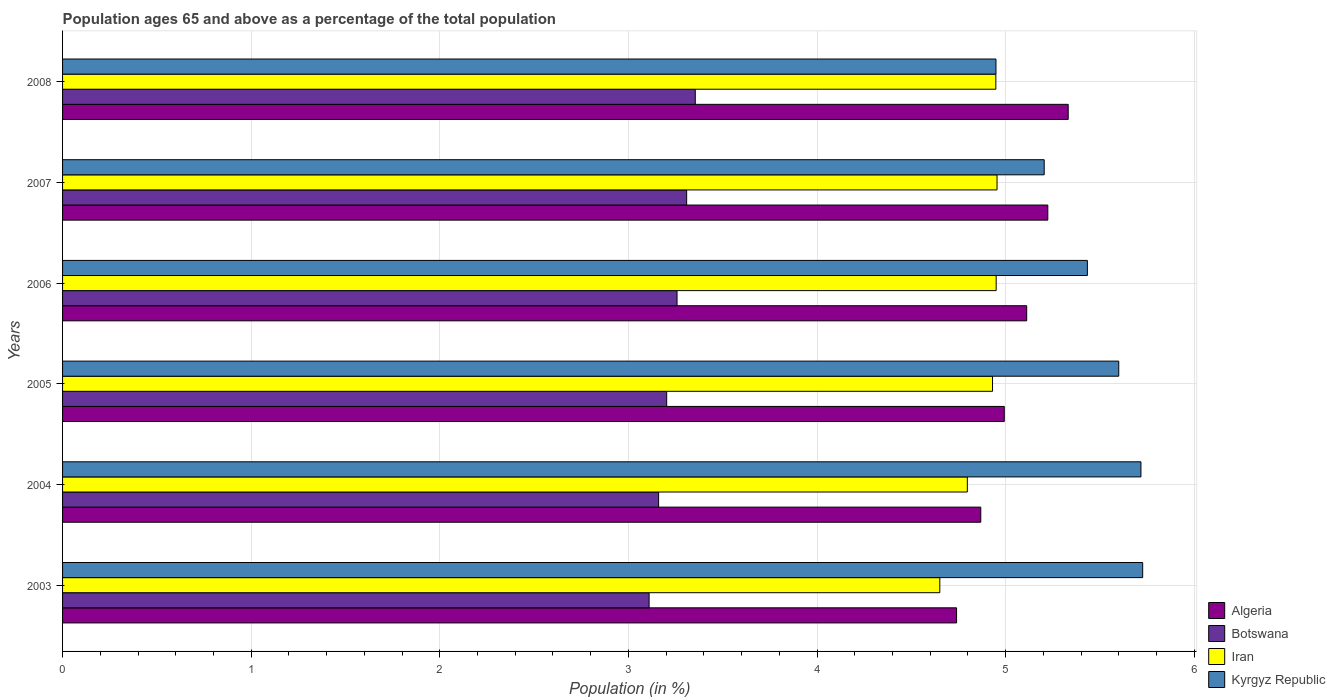Are the number of bars on each tick of the Y-axis equal?
Ensure brevity in your answer.  Yes. How many bars are there on the 2nd tick from the top?
Give a very brief answer. 4. What is the percentage of the population ages 65 and above in Botswana in 2008?
Make the answer very short. 3.35. Across all years, what is the maximum percentage of the population ages 65 and above in Iran?
Provide a succinct answer. 4.95. Across all years, what is the minimum percentage of the population ages 65 and above in Algeria?
Offer a terse response. 4.74. What is the total percentage of the population ages 65 and above in Algeria in the graph?
Offer a terse response. 30.27. What is the difference between the percentage of the population ages 65 and above in Algeria in 2006 and that in 2008?
Your answer should be very brief. -0.22. What is the difference between the percentage of the population ages 65 and above in Iran in 2005 and the percentage of the population ages 65 and above in Botswana in 2008?
Provide a short and direct response. 1.58. What is the average percentage of the population ages 65 and above in Botswana per year?
Offer a very short reply. 3.23. In the year 2008, what is the difference between the percentage of the population ages 65 and above in Botswana and percentage of the population ages 65 and above in Iran?
Provide a succinct answer. -1.59. In how many years, is the percentage of the population ages 65 and above in Iran greater than 4 ?
Your answer should be compact. 6. What is the ratio of the percentage of the population ages 65 and above in Algeria in 2004 to that in 2006?
Offer a very short reply. 0.95. Is the percentage of the population ages 65 and above in Kyrgyz Republic in 2004 less than that in 2007?
Keep it short and to the point. No. Is the difference between the percentage of the population ages 65 and above in Botswana in 2005 and 2008 greater than the difference between the percentage of the population ages 65 and above in Iran in 2005 and 2008?
Your answer should be compact. No. What is the difference between the highest and the second highest percentage of the population ages 65 and above in Kyrgyz Republic?
Keep it short and to the point. 0.01. What is the difference between the highest and the lowest percentage of the population ages 65 and above in Iran?
Your answer should be compact. 0.3. In how many years, is the percentage of the population ages 65 and above in Iran greater than the average percentage of the population ages 65 and above in Iran taken over all years?
Your answer should be very brief. 4. What does the 3rd bar from the top in 2008 represents?
Make the answer very short. Botswana. What does the 4th bar from the bottom in 2004 represents?
Your answer should be compact. Kyrgyz Republic. How many bars are there?
Provide a short and direct response. 24. Are all the bars in the graph horizontal?
Your answer should be compact. Yes. What is the difference between two consecutive major ticks on the X-axis?
Offer a very short reply. 1. Are the values on the major ticks of X-axis written in scientific E-notation?
Offer a terse response. No. Does the graph contain any zero values?
Offer a terse response. No. Does the graph contain grids?
Your answer should be compact. Yes. Where does the legend appear in the graph?
Ensure brevity in your answer.  Bottom right. What is the title of the graph?
Provide a short and direct response. Population ages 65 and above as a percentage of the total population. What is the Population (in %) in Algeria in 2003?
Ensure brevity in your answer.  4.74. What is the Population (in %) in Botswana in 2003?
Your response must be concise. 3.11. What is the Population (in %) in Iran in 2003?
Ensure brevity in your answer.  4.65. What is the Population (in %) in Kyrgyz Republic in 2003?
Your answer should be compact. 5.73. What is the Population (in %) in Algeria in 2004?
Ensure brevity in your answer.  4.87. What is the Population (in %) in Botswana in 2004?
Ensure brevity in your answer.  3.16. What is the Population (in %) in Iran in 2004?
Offer a very short reply. 4.8. What is the Population (in %) of Kyrgyz Republic in 2004?
Offer a terse response. 5.72. What is the Population (in %) of Algeria in 2005?
Your answer should be compact. 4.99. What is the Population (in %) in Botswana in 2005?
Provide a short and direct response. 3.2. What is the Population (in %) of Iran in 2005?
Provide a succinct answer. 4.93. What is the Population (in %) in Kyrgyz Republic in 2005?
Offer a terse response. 5.6. What is the Population (in %) in Algeria in 2006?
Your response must be concise. 5.11. What is the Population (in %) of Botswana in 2006?
Your answer should be compact. 3.26. What is the Population (in %) in Iran in 2006?
Offer a very short reply. 4.95. What is the Population (in %) of Kyrgyz Republic in 2006?
Keep it short and to the point. 5.43. What is the Population (in %) of Algeria in 2007?
Provide a succinct answer. 5.22. What is the Population (in %) of Botswana in 2007?
Provide a short and direct response. 3.31. What is the Population (in %) of Iran in 2007?
Ensure brevity in your answer.  4.95. What is the Population (in %) in Kyrgyz Republic in 2007?
Provide a short and direct response. 5.2. What is the Population (in %) in Algeria in 2008?
Make the answer very short. 5.33. What is the Population (in %) of Botswana in 2008?
Ensure brevity in your answer.  3.35. What is the Population (in %) in Iran in 2008?
Offer a terse response. 4.95. What is the Population (in %) of Kyrgyz Republic in 2008?
Provide a short and direct response. 4.95. Across all years, what is the maximum Population (in %) of Algeria?
Offer a terse response. 5.33. Across all years, what is the maximum Population (in %) of Botswana?
Offer a very short reply. 3.35. Across all years, what is the maximum Population (in %) of Iran?
Give a very brief answer. 4.95. Across all years, what is the maximum Population (in %) of Kyrgyz Republic?
Your response must be concise. 5.73. Across all years, what is the minimum Population (in %) in Algeria?
Offer a terse response. 4.74. Across all years, what is the minimum Population (in %) in Botswana?
Make the answer very short. 3.11. Across all years, what is the minimum Population (in %) in Iran?
Ensure brevity in your answer.  4.65. Across all years, what is the minimum Population (in %) in Kyrgyz Republic?
Your response must be concise. 4.95. What is the total Population (in %) in Algeria in the graph?
Ensure brevity in your answer.  30.27. What is the total Population (in %) in Botswana in the graph?
Your response must be concise. 19.39. What is the total Population (in %) of Iran in the graph?
Your answer should be very brief. 29.23. What is the total Population (in %) in Kyrgyz Republic in the graph?
Ensure brevity in your answer.  32.63. What is the difference between the Population (in %) in Algeria in 2003 and that in 2004?
Your answer should be very brief. -0.13. What is the difference between the Population (in %) in Botswana in 2003 and that in 2004?
Provide a succinct answer. -0.05. What is the difference between the Population (in %) in Iran in 2003 and that in 2004?
Your answer should be very brief. -0.15. What is the difference between the Population (in %) in Kyrgyz Republic in 2003 and that in 2004?
Your answer should be compact. 0.01. What is the difference between the Population (in %) of Algeria in 2003 and that in 2005?
Keep it short and to the point. -0.25. What is the difference between the Population (in %) in Botswana in 2003 and that in 2005?
Offer a very short reply. -0.09. What is the difference between the Population (in %) in Iran in 2003 and that in 2005?
Provide a short and direct response. -0.28. What is the difference between the Population (in %) of Kyrgyz Republic in 2003 and that in 2005?
Ensure brevity in your answer.  0.13. What is the difference between the Population (in %) of Algeria in 2003 and that in 2006?
Provide a succinct answer. -0.37. What is the difference between the Population (in %) in Botswana in 2003 and that in 2006?
Give a very brief answer. -0.15. What is the difference between the Population (in %) in Iran in 2003 and that in 2006?
Provide a short and direct response. -0.3. What is the difference between the Population (in %) in Kyrgyz Republic in 2003 and that in 2006?
Provide a short and direct response. 0.29. What is the difference between the Population (in %) of Algeria in 2003 and that in 2007?
Make the answer very short. -0.48. What is the difference between the Population (in %) of Botswana in 2003 and that in 2007?
Your answer should be compact. -0.2. What is the difference between the Population (in %) in Iran in 2003 and that in 2007?
Keep it short and to the point. -0.3. What is the difference between the Population (in %) in Kyrgyz Republic in 2003 and that in 2007?
Make the answer very short. 0.52. What is the difference between the Population (in %) of Algeria in 2003 and that in 2008?
Your answer should be very brief. -0.59. What is the difference between the Population (in %) in Botswana in 2003 and that in 2008?
Offer a terse response. -0.24. What is the difference between the Population (in %) of Iran in 2003 and that in 2008?
Ensure brevity in your answer.  -0.3. What is the difference between the Population (in %) in Algeria in 2004 and that in 2005?
Your response must be concise. -0.12. What is the difference between the Population (in %) of Botswana in 2004 and that in 2005?
Give a very brief answer. -0.04. What is the difference between the Population (in %) of Iran in 2004 and that in 2005?
Your answer should be compact. -0.13. What is the difference between the Population (in %) in Kyrgyz Republic in 2004 and that in 2005?
Your answer should be very brief. 0.12. What is the difference between the Population (in %) in Algeria in 2004 and that in 2006?
Provide a short and direct response. -0.24. What is the difference between the Population (in %) of Botswana in 2004 and that in 2006?
Your response must be concise. -0.1. What is the difference between the Population (in %) of Iran in 2004 and that in 2006?
Make the answer very short. -0.15. What is the difference between the Population (in %) of Kyrgyz Republic in 2004 and that in 2006?
Offer a very short reply. 0.28. What is the difference between the Population (in %) of Algeria in 2004 and that in 2007?
Offer a terse response. -0.36. What is the difference between the Population (in %) in Botswana in 2004 and that in 2007?
Keep it short and to the point. -0.15. What is the difference between the Population (in %) in Iran in 2004 and that in 2007?
Keep it short and to the point. -0.16. What is the difference between the Population (in %) of Kyrgyz Republic in 2004 and that in 2007?
Give a very brief answer. 0.51. What is the difference between the Population (in %) in Algeria in 2004 and that in 2008?
Your response must be concise. -0.46. What is the difference between the Population (in %) of Botswana in 2004 and that in 2008?
Provide a succinct answer. -0.19. What is the difference between the Population (in %) in Iran in 2004 and that in 2008?
Offer a very short reply. -0.15. What is the difference between the Population (in %) of Kyrgyz Republic in 2004 and that in 2008?
Give a very brief answer. 0.77. What is the difference between the Population (in %) in Algeria in 2005 and that in 2006?
Your response must be concise. -0.12. What is the difference between the Population (in %) in Botswana in 2005 and that in 2006?
Offer a terse response. -0.05. What is the difference between the Population (in %) of Iran in 2005 and that in 2006?
Your response must be concise. -0.02. What is the difference between the Population (in %) of Kyrgyz Republic in 2005 and that in 2006?
Your response must be concise. 0.17. What is the difference between the Population (in %) in Algeria in 2005 and that in 2007?
Offer a very short reply. -0.23. What is the difference between the Population (in %) of Botswana in 2005 and that in 2007?
Offer a very short reply. -0.11. What is the difference between the Population (in %) of Iran in 2005 and that in 2007?
Make the answer very short. -0.02. What is the difference between the Population (in %) in Kyrgyz Republic in 2005 and that in 2007?
Provide a short and direct response. 0.4. What is the difference between the Population (in %) in Algeria in 2005 and that in 2008?
Offer a terse response. -0.34. What is the difference between the Population (in %) of Botswana in 2005 and that in 2008?
Your response must be concise. -0.15. What is the difference between the Population (in %) of Iran in 2005 and that in 2008?
Ensure brevity in your answer.  -0.02. What is the difference between the Population (in %) in Kyrgyz Republic in 2005 and that in 2008?
Provide a short and direct response. 0.65. What is the difference between the Population (in %) in Algeria in 2006 and that in 2007?
Your answer should be very brief. -0.11. What is the difference between the Population (in %) in Botswana in 2006 and that in 2007?
Provide a short and direct response. -0.05. What is the difference between the Population (in %) of Iran in 2006 and that in 2007?
Ensure brevity in your answer.  -0. What is the difference between the Population (in %) in Kyrgyz Republic in 2006 and that in 2007?
Your response must be concise. 0.23. What is the difference between the Population (in %) in Algeria in 2006 and that in 2008?
Provide a succinct answer. -0.22. What is the difference between the Population (in %) in Botswana in 2006 and that in 2008?
Offer a very short reply. -0.1. What is the difference between the Population (in %) in Iran in 2006 and that in 2008?
Your response must be concise. 0. What is the difference between the Population (in %) of Kyrgyz Republic in 2006 and that in 2008?
Make the answer very short. 0.48. What is the difference between the Population (in %) in Algeria in 2007 and that in 2008?
Provide a succinct answer. -0.11. What is the difference between the Population (in %) in Botswana in 2007 and that in 2008?
Your response must be concise. -0.05. What is the difference between the Population (in %) in Iran in 2007 and that in 2008?
Give a very brief answer. 0.01. What is the difference between the Population (in %) in Kyrgyz Republic in 2007 and that in 2008?
Your answer should be compact. 0.26. What is the difference between the Population (in %) in Algeria in 2003 and the Population (in %) in Botswana in 2004?
Offer a terse response. 1.58. What is the difference between the Population (in %) of Algeria in 2003 and the Population (in %) of Iran in 2004?
Give a very brief answer. -0.06. What is the difference between the Population (in %) in Algeria in 2003 and the Population (in %) in Kyrgyz Republic in 2004?
Offer a very short reply. -0.98. What is the difference between the Population (in %) of Botswana in 2003 and the Population (in %) of Iran in 2004?
Offer a terse response. -1.69. What is the difference between the Population (in %) of Botswana in 2003 and the Population (in %) of Kyrgyz Republic in 2004?
Provide a succinct answer. -2.61. What is the difference between the Population (in %) of Iran in 2003 and the Population (in %) of Kyrgyz Republic in 2004?
Your answer should be very brief. -1.07. What is the difference between the Population (in %) in Algeria in 2003 and the Population (in %) in Botswana in 2005?
Make the answer very short. 1.54. What is the difference between the Population (in %) in Algeria in 2003 and the Population (in %) in Iran in 2005?
Make the answer very short. -0.19. What is the difference between the Population (in %) in Algeria in 2003 and the Population (in %) in Kyrgyz Republic in 2005?
Your answer should be compact. -0.86. What is the difference between the Population (in %) in Botswana in 2003 and the Population (in %) in Iran in 2005?
Your response must be concise. -1.82. What is the difference between the Population (in %) of Botswana in 2003 and the Population (in %) of Kyrgyz Republic in 2005?
Keep it short and to the point. -2.49. What is the difference between the Population (in %) in Iran in 2003 and the Population (in %) in Kyrgyz Republic in 2005?
Make the answer very short. -0.95. What is the difference between the Population (in %) in Algeria in 2003 and the Population (in %) in Botswana in 2006?
Keep it short and to the point. 1.48. What is the difference between the Population (in %) of Algeria in 2003 and the Population (in %) of Iran in 2006?
Provide a succinct answer. -0.21. What is the difference between the Population (in %) in Algeria in 2003 and the Population (in %) in Kyrgyz Republic in 2006?
Your response must be concise. -0.69. What is the difference between the Population (in %) of Botswana in 2003 and the Population (in %) of Iran in 2006?
Make the answer very short. -1.84. What is the difference between the Population (in %) of Botswana in 2003 and the Population (in %) of Kyrgyz Republic in 2006?
Give a very brief answer. -2.32. What is the difference between the Population (in %) in Iran in 2003 and the Population (in %) in Kyrgyz Republic in 2006?
Offer a terse response. -0.78. What is the difference between the Population (in %) in Algeria in 2003 and the Population (in %) in Botswana in 2007?
Provide a succinct answer. 1.43. What is the difference between the Population (in %) of Algeria in 2003 and the Population (in %) of Iran in 2007?
Ensure brevity in your answer.  -0.21. What is the difference between the Population (in %) in Algeria in 2003 and the Population (in %) in Kyrgyz Republic in 2007?
Offer a terse response. -0.46. What is the difference between the Population (in %) of Botswana in 2003 and the Population (in %) of Iran in 2007?
Offer a very short reply. -1.84. What is the difference between the Population (in %) in Botswana in 2003 and the Population (in %) in Kyrgyz Republic in 2007?
Provide a short and direct response. -2.09. What is the difference between the Population (in %) of Iran in 2003 and the Population (in %) of Kyrgyz Republic in 2007?
Make the answer very short. -0.55. What is the difference between the Population (in %) in Algeria in 2003 and the Population (in %) in Botswana in 2008?
Ensure brevity in your answer.  1.39. What is the difference between the Population (in %) in Algeria in 2003 and the Population (in %) in Iran in 2008?
Your response must be concise. -0.21. What is the difference between the Population (in %) of Algeria in 2003 and the Population (in %) of Kyrgyz Republic in 2008?
Your answer should be compact. -0.21. What is the difference between the Population (in %) in Botswana in 2003 and the Population (in %) in Iran in 2008?
Make the answer very short. -1.84. What is the difference between the Population (in %) of Botswana in 2003 and the Population (in %) of Kyrgyz Republic in 2008?
Give a very brief answer. -1.84. What is the difference between the Population (in %) of Iran in 2003 and the Population (in %) of Kyrgyz Republic in 2008?
Make the answer very short. -0.3. What is the difference between the Population (in %) in Algeria in 2004 and the Population (in %) in Botswana in 2005?
Keep it short and to the point. 1.67. What is the difference between the Population (in %) of Algeria in 2004 and the Population (in %) of Iran in 2005?
Provide a short and direct response. -0.06. What is the difference between the Population (in %) of Algeria in 2004 and the Population (in %) of Kyrgyz Republic in 2005?
Make the answer very short. -0.73. What is the difference between the Population (in %) of Botswana in 2004 and the Population (in %) of Iran in 2005?
Your answer should be compact. -1.77. What is the difference between the Population (in %) of Botswana in 2004 and the Population (in %) of Kyrgyz Republic in 2005?
Ensure brevity in your answer.  -2.44. What is the difference between the Population (in %) in Iran in 2004 and the Population (in %) in Kyrgyz Republic in 2005?
Provide a short and direct response. -0.8. What is the difference between the Population (in %) in Algeria in 2004 and the Population (in %) in Botswana in 2006?
Your answer should be compact. 1.61. What is the difference between the Population (in %) of Algeria in 2004 and the Population (in %) of Iran in 2006?
Provide a short and direct response. -0.08. What is the difference between the Population (in %) in Algeria in 2004 and the Population (in %) in Kyrgyz Republic in 2006?
Offer a terse response. -0.57. What is the difference between the Population (in %) in Botswana in 2004 and the Population (in %) in Iran in 2006?
Ensure brevity in your answer.  -1.79. What is the difference between the Population (in %) of Botswana in 2004 and the Population (in %) of Kyrgyz Republic in 2006?
Provide a succinct answer. -2.27. What is the difference between the Population (in %) in Iran in 2004 and the Population (in %) in Kyrgyz Republic in 2006?
Keep it short and to the point. -0.64. What is the difference between the Population (in %) of Algeria in 2004 and the Population (in %) of Botswana in 2007?
Offer a very short reply. 1.56. What is the difference between the Population (in %) of Algeria in 2004 and the Population (in %) of Iran in 2007?
Make the answer very short. -0.09. What is the difference between the Population (in %) of Algeria in 2004 and the Population (in %) of Kyrgyz Republic in 2007?
Your answer should be compact. -0.34. What is the difference between the Population (in %) of Botswana in 2004 and the Population (in %) of Iran in 2007?
Offer a terse response. -1.79. What is the difference between the Population (in %) of Botswana in 2004 and the Population (in %) of Kyrgyz Republic in 2007?
Ensure brevity in your answer.  -2.04. What is the difference between the Population (in %) of Iran in 2004 and the Population (in %) of Kyrgyz Republic in 2007?
Your answer should be compact. -0.41. What is the difference between the Population (in %) in Algeria in 2004 and the Population (in %) in Botswana in 2008?
Offer a very short reply. 1.51. What is the difference between the Population (in %) of Algeria in 2004 and the Population (in %) of Iran in 2008?
Offer a very short reply. -0.08. What is the difference between the Population (in %) in Algeria in 2004 and the Population (in %) in Kyrgyz Republic in 2008?
Provide a short and direct response. -0.08. What is the difference between the Population (in %) in Botswana in 2004 and the Population (in %) in Iran in 2008?
Your answer should be very brief. -1.79. What is the difference between the Population (in %) in Botswana in 2004 and the Population (in %) in Kyrgyz Republic in 2008?
Give a very brief answer. -1.79. What is the difference between the Population (in %) of Iran in 2004 and the Population (in %) of Kyrgyz Republic in 2008?
Provide a succinct answer. -0.15. What is the difference between the Population (in %) of Algeria in 2005 and the Population (in %) of Botswana in 2006?
Make the answer very short. 1.73. What is the difference between the Population (in %) in Algeria in 2005 and the Population (in %) in Iran in 2006?
Offer a very short reply. 0.04. What is the difference between the Population (in %) in Algeria in 2005 and the Population (in %) in Kyrgyz Republic in 2006?
Provide a short and direct response. -0.44. What is the difference between the Population (in %) of Botswana in 2005 and the Population (in %) of Iran in 2006?
Offer a terse response. -1.75. What is the difference between the Population (in %) of Botswana in 2005 and the Population (in %) of Kyrgyz Republic in 2006?
Provide a short and direct response. -2.23. What is the difference between the Population (in %) in Iran in 2005 and the Population (in %) in Kyrgyz Republic in 2006?
Offer a terse response. -0.5. What is the difference between the Population (in %) of Algeria in 2005 and the Population (in %) of Botswana in 2007?
Your answer should be compact. 1.68. What is the difference between the Population (in %) of Algeria in 2005 and the Population (in %) of Iran in 2007?
Your answer should be compact. 0.04. What is the difference between the Population (in %) of Algeria in 2005 and the Population (in %) of Kyrgyz Republic in 2007?
Ensure brevity in your answer.  -0.21. What is the difference between the Population (in %) of Botswana in 2005 and the Population (in %) of Iran in 2007?
Provide a short and direct response. -1.75. What is the difference between the Population (in %) in Botswana in 2005 and the Population (in %) in Kyrgyz Republic in 2007?
Your response must be concise. -2. What is the difference between the Population (in %) of Iran in 2005 and the Population (in %) of Kyrgyz Republic in 2007?
Offer a terse response. -0.27. What is the difference between the Population (in %) of Algeria in 2005 and the Population (in %) of Botswana in 2008?
Offer a terse response. 1.64. What is the difference between the Population (in %) in Algeria in 2005 and the Population (in %) in Iran in 2008?
Offer a very short reply. 0.04. What is the difference between the Population (in %) of Algeria in 2005 and the Population (in %) of Kyrgyz Republic in 2008?
Your answer should be compact. 0.04. What is the difference between the Population (in %) of Botswana in 2005 and the Population (in %) of Iran in 2008?
Keep it short and to the point. -1.75. What is the difference between the Population (in %) of Botswana in 2005 and the Population (in %) of Kyrgyz Republic in 2008?
Your answer should be very brief. -1.75. What is the difference between the Population (in %) of Iran in 2005 and the Population (in %) of Kyrgyz Republic in 2008?
Offer a terse response. -0.02. What is the difference between the Population (in %) in Algeria in 2006 and the Population (in %) in Botswana in 2007?
Provide a short and direct response. 1.8. What is the difference between the Population (in %) of Algeria in 2006 and the Population (in %) of Iran in 2007?
Your response must be concise. 0.16. What is the difference between the Population (in %) in Algeria in 2006 and the Population (in %) in Kyrgyz Republic in 2007?
Give a very brief answer. -0.09. What is the difference between the Population (in %) of Botswana in 2006 and the Population (in %) of Iran in 2007?
Offer a very short reply. -1.7. What is the difference between the Population (in %) in Botswana in 2006 and the Population (in %) in Kyrgyz Republic in 2007?
Your answer should be very brief. -1.95. What is the difference between the Population (in %) in Iran in 2006 and the Population (in %) in Kyrgyz Republic in 2007?
Provide a succinct answer. -0.25. What is the difference between the Population (in %) in Algeria in 2006 and the Population (in %) in Botswana in 2008?
Your answer should be very brief. 1.76. What is the difference between the Population (in %) of Algeria in 2006 and the Population (in %) of Iran in 2008?
Your answer should be very brief. 0.16. What is the difference between the Population (in %) in Algeria in 2006 and the Population (in %) in Kyrgyz Republic in 2008?
Your answer should be compact. 0.16. What is the difference between the Population (in %) of Botswana in 2006 and the Population (in %) of Iran in 2008?
Provide a short and direct response. -1.69. What is the difference between the Population (in %) of Botswana in 2006 and the Population (in %) of Kyrgyz Republic in 2008?
Offer a very short reply. -1.69. What is the difference between the Population (in %) in Iran in 2006 and the Population (in %) in Kyrgyz Republic in 2008?
Offer a very short reply. 0. What is the difference between the Population (in %) of Algeria in 2007 and the Population (in %) of Botswana in 2008?
Provide a succinct answer. 1.87. What is the difference between the Population (in %) in Algeria in 2007 and the Population (in %) in Iran in 2008?
Keep it short and to the point. 0.28. What is the difference between the Population (in %) of Algeria in 2007 and the Population (in %) of Kyrgyz Republic in 2008?
Keep it short and to the point. 0.27. What is the difference between the Population (in %) in Botswana in 2007 and the Population (in %) in Iran in 2008?
Your answer should be very brief. -1.64. What is the difference between the Population (in %) of Botswana in 2007 and the Population (in %) of Kyrgyz Republic in 2008?
Make the answer very short. -1.64. What is the difference between the Population (in %) in Iran in 2007 and the Population (in %) in Kyrgyz Republic in 2008?
Your answer should be compact. 0.01. What is the average Population (in %) of Algeria per year?
Provide a short and direct response. 5.04. What is the average Population (in %) of Botswana per year?
Offer a terse response. 3.23. What is the average Population (in %) of Iran per year?
Your answer should be very brief. 4.87. What is the average Population (in %) of Kyrgyz Republic per year?
Give a very brief answer. 5.44. In the year 2003, what is the difference between the Population (in %) of Algeria and Population (in %) of Botswana?
Make the answer very short. 1.63. In the year 2003, what is the difference between the Population (in %) of Algeria and Population (in %) of Iran?
Your answer should be very brief. 0.09. In the year 2003, what is the difference between the Population (in %) in Algeria and Population (in %) in Kyrgyz Republic?
Your answer should be compact. -0.99. In the year 2003, what is the difference between the Population (in %) of Botswana and Population (in %) of Iran?
Provide a succinct answer. -1.54. In the year 2003, what is the difference between the Population (in %) in Botswana and Population (in %) in Kyrgyz Republic?
Keep it short and to the point. -2.62. In the year 2003, what is the difference between the Population (in %) in Iran and Population (in %) in Kyrgyz Republic?
Provide a succinct answer. -1.08. In the year 2004, what is the difference between the Population (in %) in Algeria and Population (in %) in Botswana?
Make the answer very short. 1.71. In the year 2004, what is the difference between the Population (in %) in Algeria and Population (in %) in Iran?
Your answer should be very brief. 0.07. In the year 2004, what is the difference between the Population (in %) in Algeria and Population (in %) in Kyrgyz Republic?
Your response must be concise. -0.85. In the year 2004, what is the difference between the Population (in %) in Botswana and Population (in %) in Iran?
Provide a short and direct response. -1.64. In the year 2004, what is the difference between the Population (in %) in Botswana and Population (in %) in Kyrgyz Republic?
Your response must be concise. -2.56. In the year 2004, what is the difference between the Population (in %) of Iran and Population (in %) of Kyrgyz Republic?
Provide a succinct answer. -0.92. In the year 2005, what is the difference between the Population (in %) in Algeria and Population (in %) in Botswana?
Your answer should be compact. 1.79. In the year 2005, what is the difference between the Population (in %) of Algeria and Population (in %) of Iran?
Make the answer very short. 0.06. In the year 2005, what is the difference between the Population (in %) of Algeria and Population (in %) of Kyrgyz Republic?
Offer a very short reply. -0.61. In the year 2005, what is the difference between the Population (in %) of Botswana and Population (in %) of Iran?
Provide a succinct answer. -1.73. In the year 2005, what is the difference between the Population (in %) of Botswana and Population (in %) of Kyrgyz Republic?
Provide a short and direct response. -2.4. In the year 2005, what is the difference between the Population (in %) in Iran and Population (in %) in Kyrgyz Republic?
Give a very brief answer. -0.67. In the year 2006, what is the difference between the Population (in %) of Algeria and Population (in %) of Botswana?
Provide a succinct answer. 1.85. In the year 2006, what is the difference between the Population (in %) of Algeria and Population (in %) of Iran?
Ensure brevity in your answer.  0.16. In the year 2006, what is the difference between the Population (in %) in Algeria and Population (in %) in Kyrgyz Republic?
Your answer should be compact. -0.32. In the year 2006, what is the difference between the Population (in %) in Botswana and Population (in %) in Iran?
Your answer should be very brief. -1.69. In the year 2006, what is the difference between the Population (in %) in Botswana and Population (in %) in Kyrgyz Republic?
Give a very brief answer. -2.18. In the year 2006, what is the difference between the Population (in %) of Iran and Population (in %) of Kyrgyz Republic?
Your answer should be compact. -0.48. In the year 2007, what is the difference between the Population (in %) of Algeria and Population (in %) of Botswana?
Provide a succinct answer. 1.91. In the year 2007, what is the difference between the Population (in %) of Algeria and Population (in %) of Iran?
Your answer should be very brief. 0.27. In the year 2007, what is the difference between the Population (in %) in Algeria and Population (in %) in Kyrgyz Republic?
Provide a succinct answer. 0.02. In the year 2007, what is the difference between the Population (in %) of Botswana and Population (in %) of Iran?
Your answer should be very brief. -1.65. In the year 2007, what is the difference between the Population (in %) in Botswana and Population (in %) in Kyrgyz Republic?
Your response must be concise. -1.9. In the year 2007, what is the difference between the Population (in %) in Iran and Population (in %) in Kyrgyz Republic?
Offer a terse response. -0.25. In the year 2008, what is the difference between the Population (in %) of Algeria and Population (in %) of Botswana?
Provide a short and direct response. 1.98. In the year 2008, what is the difference between the Population (in %) of Algeria and Population (in %) of Iran?
Your answer should be very brief. 0.38. In the year 2008, what is the difference between the Population (in %) in Algeria and Population (in %) in Kyrgyz Republic?
Provide a succinct answer. 0.38. In the year 2008, what is the difference between the Population (in %) in Botswana and Population (in %) in Iran?
Your response must be concise. -1.59. In the year 2008, what is the difference between the Population (in %) of Botswana and Population (in %) of Kyrgyz Republic?
Your response must be concise. -1.59. In the year 2008, what is the difference between the Population (in %) in Iran and Population (in %) in Kyrgyz Republic?
Make the answer very short. -0. What is the ratio of the Population (in %) in Algeria in 2003 to that in 2004?
Offer a very short reply. 0.97. What is the ratio of the Population (in %) of Botswana in 2003 to that in 2004?
Make the answer very short. 0.98. What is the ratio of the Population (in %) of Iran in 2003 to that in 2004?
Offer a terse response. 0.97. What is the ratio of the Population (in %) of Algeria in 2003 to that in 2005?
Your answer should be compact. 0.95. What is the ratio of the Population (in %) of Botswana in 2003 to that in 2005?
Make the answer very short. 0.97. What is the ratio of the Population (in %) of Iran in 2003 to that in 2005?
Keep it short and to the point. 0.94. What is the ratio of the Population (in %) in Kyrgyz Republic in 2003 to that in 2005?
Offer a very short reply. 1.02. What is the ratio of the Population (in %) in Algeria in 2003 to that in 2006?
Provide a succinct answer. 0.93. What is the ratio of the Population (in %) of Botswana in 2003 to that in 2006?
Keep it short and to the point. 0.95. What is the ratio of the Population (in %) of Iran in 2003 to that in 2006?
Keep it short and to the point. 0.94. What is the ratio of the Population (in %) of Kyrgyz Republic in 2003 to that in 2006?
Provide a short and direct response. 1.05. What is the ratio of the Population (in %) in Algeria in 2003 to that in 2007?
Your answer should be compact. 0.91. What is the ratio of the Population (in %) in Botswana in 2003 to that in 2007?
Provide a succinct answer. 0.94. What is the ratio of the Population (in %) of Iran in 2003 to that in 2007?
Make the answer very short. 0.94. What is the ratio of the Population (in %) in Kyrgyz Republic in 2003 to that in 2007?
Your response must be concise. 1.1. What is the ratio of the Population (in %) in Algeria in 2003 to that in 2008?
Provide a short and direct response. 0.89. What is the ratio of the Population (in %) in Botswana in 2003 to that in 2008?
Provide a succinct answer. 0.93. What is the ratio of the Population (in %) in Iran in 2003 to that in 2008?
Your answer should be very brief. 0.94. What is the ratio of the Population (in %) of Kyrgyz Republic in 2003 to that in 2008?
Keep it short and to the point. 1.16. What is the ratio of the Population (in %) of Algeria in 2004 to that in 2005?
Offer a terse response. 0.97. What is the ratio of the Population (in %) in Botswana in 2004 to that in 2005?
Ensure brevity in your answer.  0.99. What is the ratio of the Population (in %) of Iran in 2004 to that in 2005?
Your response must be concise. 0.97. What is the ratio of the Population (in %) in Iran in 2004 to that in 2006?
Offer a very short reply. 0.97. What is the ratio of the Population (in %) of Kyrgyz Republic in 2004 to that in 2006?
Give a very brief answer. 1.05. What is the ratio of the Population (in %) of Algeria in 2004 to that in 2007?
Offer a terse response. 0.93. What is the ratio of the Population (in %) of Botswana in 2004 to that in 2007?
Provide a succinct answer. 0.96. What is the ratio of the Population (in %) of Iran in 2004 to that in 2007?
Provide a succinct answer. 0.97. What is the ratio of the Population (in %) in Kyrgyz Republic in 2004 to that in 2007?
Make the answer very short. 1.1. What is the ratio of the Population (in %) of Algeria in 2004 to that in 2008?
Your answer should be very brief. 0.91. What is the ratio of the Population (in %) in Botswana in 2004 to that in 2008?
Provide a short and direct response. 0.94. What is the ratio of the Population (in %) in Iran in 2004 to that in 2008?
Offer a terse response. 0.97. What is the ratio of the Population (in %) in Kyrgyz Republic in 2004 to that in 2008?
Give a very brief answer. 1.16. What is the ratio of the Population (in %) of Algeria in 2005 to that in 2006?
Offer a very short reply. 0.98. What is the ratio of the Population (in %) of Botswana in 2005 to that in 2006?
Your answer should be compact. 0.98. What is the ratio of the Population (in %) of Iran in 2005 to that in 2006?
Offer a terse response. 1. What is the ratio of the Population (in %) of Kyrgyz Republic in 2005 to that in 2006?
Give a very brief answer. 1.03. What is the ratio of the Population (in %) in Algeria in 2005 to that in 2007?
Provide a short and direct response. 0.96. What is the ratio of the Population (in %) in Botswana in 2005 to that in 2007?
Keep it short and to the point. 0.97. What is the ratio of the Population (in %) of Kyrgyz Republic in 2005 to that in 2007?
Keep it short and to the point. 1.08. What is the ratio of the Population (in %) of Algeria in 2005 to that in 2008?
Offer a very short reply. 0.94. What is the ratio of the Population (in %) of Botswana in 2005 to that in 2008?
Your answer should be very brief. 0.95. What is the ratio of the Population (in %) of Iran in 2005 to that in 2008?
Offer a very short reply. 1. What is the ratio of the Population (in %) of Kyrgyz Republic in 2005 to that in 2008?
Provide a short and direct response. 1.13. What is the ratio of the Population (in %) in Algeria in 2006 to that in 2007?
Make the answer very short. 0.98. What is the ratio of the Population (in %) of Botswana in 2006 to that in 2007?
Make the answer very short. 0.98. What is the ratio of the Population (in %) of Kyrgyz Republic in 2006 to that in 2007?
Your answer should be compact. 1.04. What is the ratio of the Population (in %) of Algeria in 2006 to that in 2008?
Ensure brevity in your answer.  0.96. What is the ratio of the Population (in %) of Botswana in 2006 to that in 2008?
Keep it short and to the point. 0.97. What is the ratio of the Population (in %) in Iran in 2006 to that in 2008?
Your answer should be compact. 1. What is the ratio of the Population (in %) of Kyrgyz Republic in 2006 to that in 2008?
Your response must be concise. 1.1. What is the ratio of the Population (in %) in Algeria in 2007 to that in 2008?
Ensure brevity in your answer.  0.98. What is the ratio of the Population (in %) in Botswana in 2007 to that in 2008?
Provide a short and direct response. 0.99. What is the ratio of the Population (in %) in Kyrgyz Republic in 2007 to that in 2008?
Your response must be concise. 1.05. What is the difference between the highest and the second highest Population (in %) of Algeria?
Your response must be concise. 0.11. What is the difference between the highest and the second highest Population (in %) in Botswana?
Keep it short and to the point. 0.05. What is the difference between the highest and the second highest Population (in %) in Iran?
Keep it short and to the point. 0. What is the difference between the highest and the second highest Population (in %) of Kyrgyz Republic?
Keep it short and to the point. 0.01. What is the difference between the highest and the lowest Population (in %) of Algeria?
Ensure brevity in your answer.  0.59. What is the difference between the highest and the lowest Population (in %) in Botswana?
Give a very brief answer. 0.24. What is the difference between the highest and the lowest Population (in %) of Iran?
Your answer should be very brief. 0.3. What is the difference between the highest and the lowest Population (in %) in Kyrgyz Republic?
Your answer should be very brief. 0.78. 